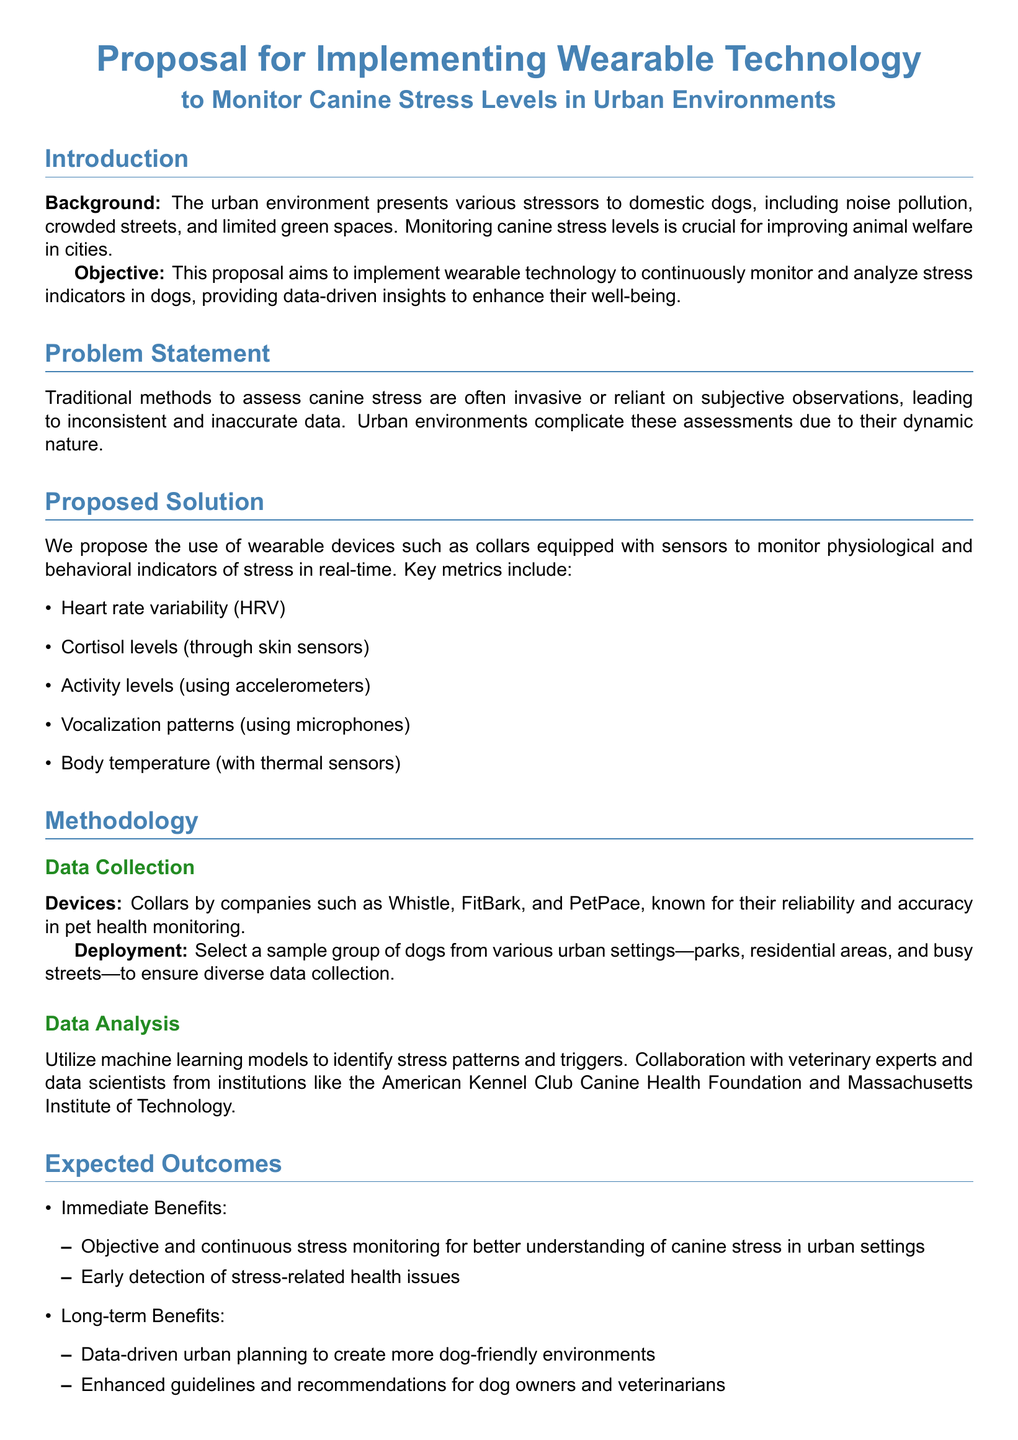what is the main objective of the proposal? The objective is to implement wearable technology to continuously monitor and analyze stress indicators in dogs, providing data-driven insights to enhance their well-being.
Answer: to continuously monitor and analyze stress indicators in dogs name one key metric to be monitored using wearable devices. The document lists several metrics, and one example is heart rate variability.
Answer: heart rate variability how long is the pilot study phase? The implementation timeline specifies that the pilot study phase is 3 months long.
Answer: 3 months what is the total estimated budget for full-scale deployment? The budget estimate for full-scale deployment is $50,000.
Answer: $50,000 who are the proposed collaborators in this study? The document mentions collaboration with veterinary experts and data scientists from institutions like the American Kennel Club Canine Health Foundation and Massachusetts Institute of Technology.
Answer: veterinary experts and data scientists from institutions like the American Kennel Club Canine Health Foundation and MIT what is one immediate benefit of the proposed solution? One immediate benefit mentioned is objective and continuous stress monitoring for better understanding of canine stress in urban settings.
Answer: objective and continuous stress monitoring how many phases are outlined in the implementation timeline? The implementation timeline outlines three phases.
Answer: three phases what technology is suggested for monitoring cortisol levels? The document suggests using skin sensors to monitor cortisol levels.
Answer: skin sensors what type of document is this? This document is a proposal.
Answer: proposal 